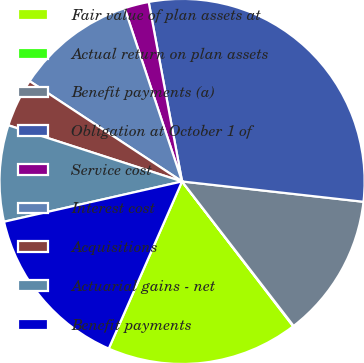Convert chart to OTSL. <chart><loc_0><loc_0><loc_500><loc_500><pie_chart><fcel>Fair value of plan assets at<fcel>Actual return on plan assets<fcel>Benefit payments (a)<fcel>Obligation at October 1 of<fcel>Service cost<fcel>Interest cost<fcel>Acquisitions<fcel>Actuarial gains - net<fcel>Benefit payments<nl><fcel>17.0%<fcel>0.05%<fcel>12.76%<fcel>29.71%<fcel>2.17%<fcel>10.64%<fcel>4.29%<fcel>8.52%<fcel>14.88%<nl></chart> 